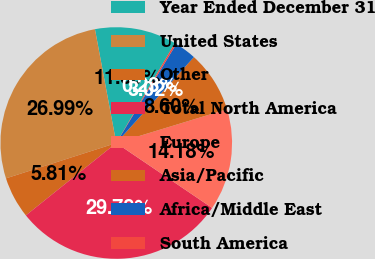Convert chart to OTSL. <chart><loc_0><loc_0><loc_500><loc_500><pie_chart><fcel>Year Ended December 31<fcel>United States<fcel>Other<fcel>Total North America<fcel>Europe<fcel>Asia/Pacific<fcel>Africa/Middle East<fcel>South America<nl><fcel>11.39%<fcel>26.99%<fcel>5.81%<fcel>29.78%<fcel>14.18%<fcel>8.6%<fcel>3.02%<fcel>0.23%<nl></chart> 